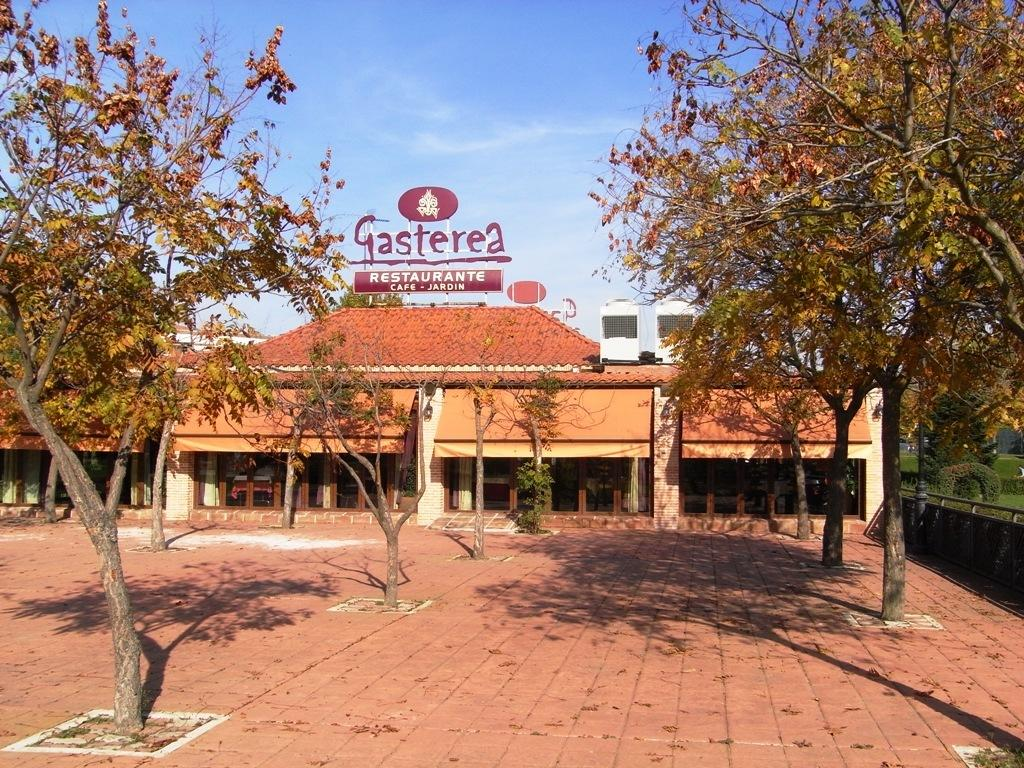What type of vegetation can be seen in the image? There are trees in the image. What is visible in the background of the image? There is a building and the sky visible in the background of the image. What can be seen on the right side of the image? There is a fence, a pole, and grass on the right side of the image. What type of creature is playing a note on the pole in the image? There is no creature or note present on the pole in the image. What type of journey is depicted in the image? There is no journey depicted in the image; it features trees, a building, the sky, a fence, a pole, and grass. 